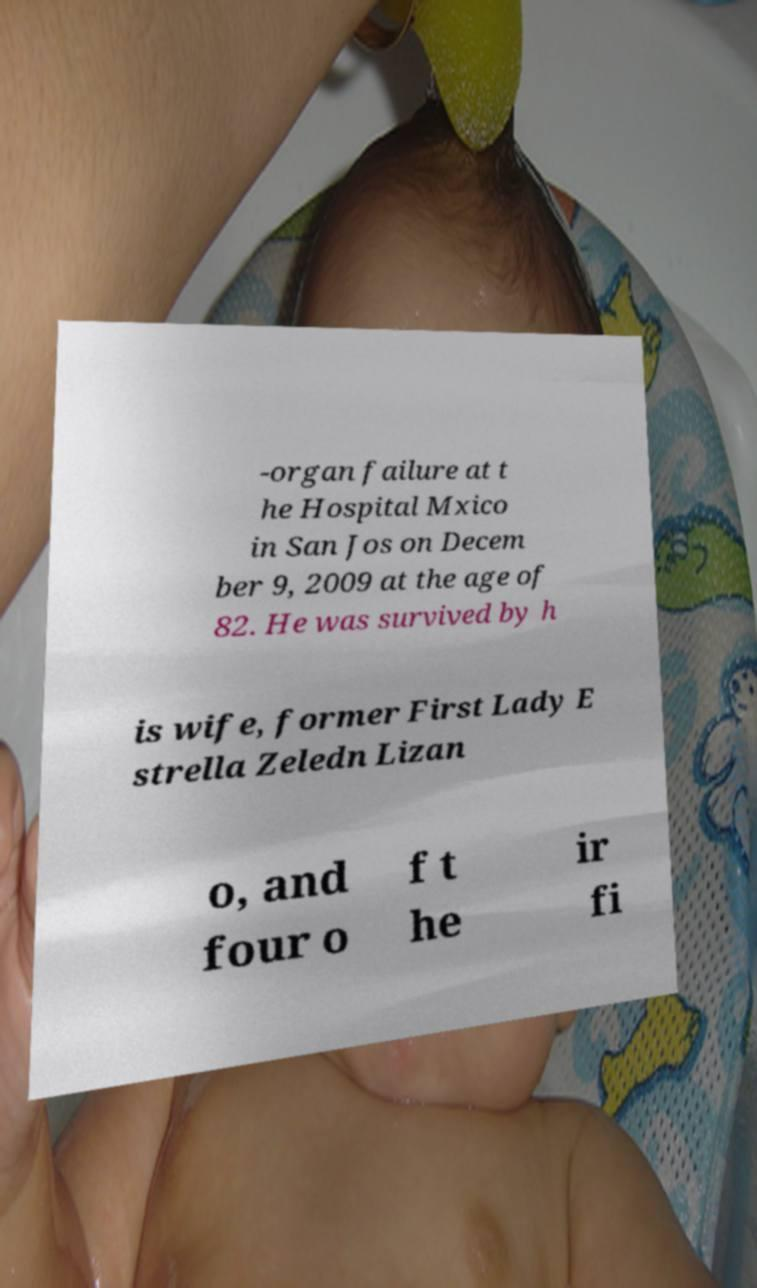For documentation purposes, I need the text within this image transcribed. Could you provide that? -organ failure at t he Hospital Mxico in San Jos on Decem ber 9, 2009 at the age of 82. He was survived by h is wife, former First Lady E strella Zeledn Lizan o, and four o f t he ir fi 